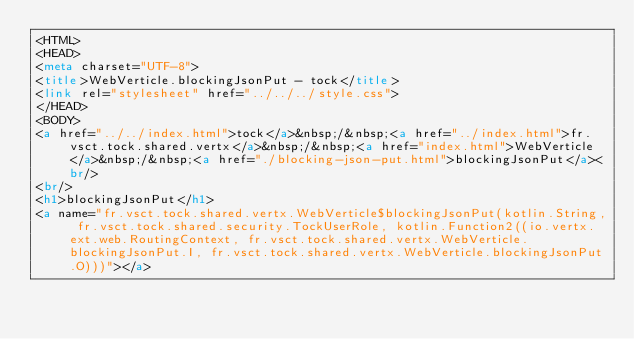Convert code to text. <code><loc_0><loc_0><loc_500><loc_500><_HTML_><HTML>
<HEAD>
<meta charset="UTF-8">
<title>WebVerticle.blockingJsonPut - tock</title>
<link rel="stylesheet" href="../../../style.css">
</HEAD>
<BODY>
<a href="../../index.html">tock</a>&nbsp;/&nbsp;<a href="../index.html">fr.vsct.tock.shared.vertx</a>&nbsp;/&nbsp;<a href="index.html">WebVerticle</a>&nbsp;/&nbsp;<a href="./blocking-json-put.html">blockingJsonPut</a><br/>
<br/>
<h1>blockingJsonPut</h1>
<a name="fr.vsct.tock.shared.vertx.WebVerticle$blockingJsonPut(kotlin.String, fr.vsct.tock.shared.security.TockUserRole, kotlin.Function2((io.vertx.ext.web.RoutingContext, fr.vsct.tock.shared.vertx.WebVerticle.blockingJsonPut.I, fr.vsct.tock.shared.vertx.WebVerticle.blockingJsonPut.O)))"></a></code> 